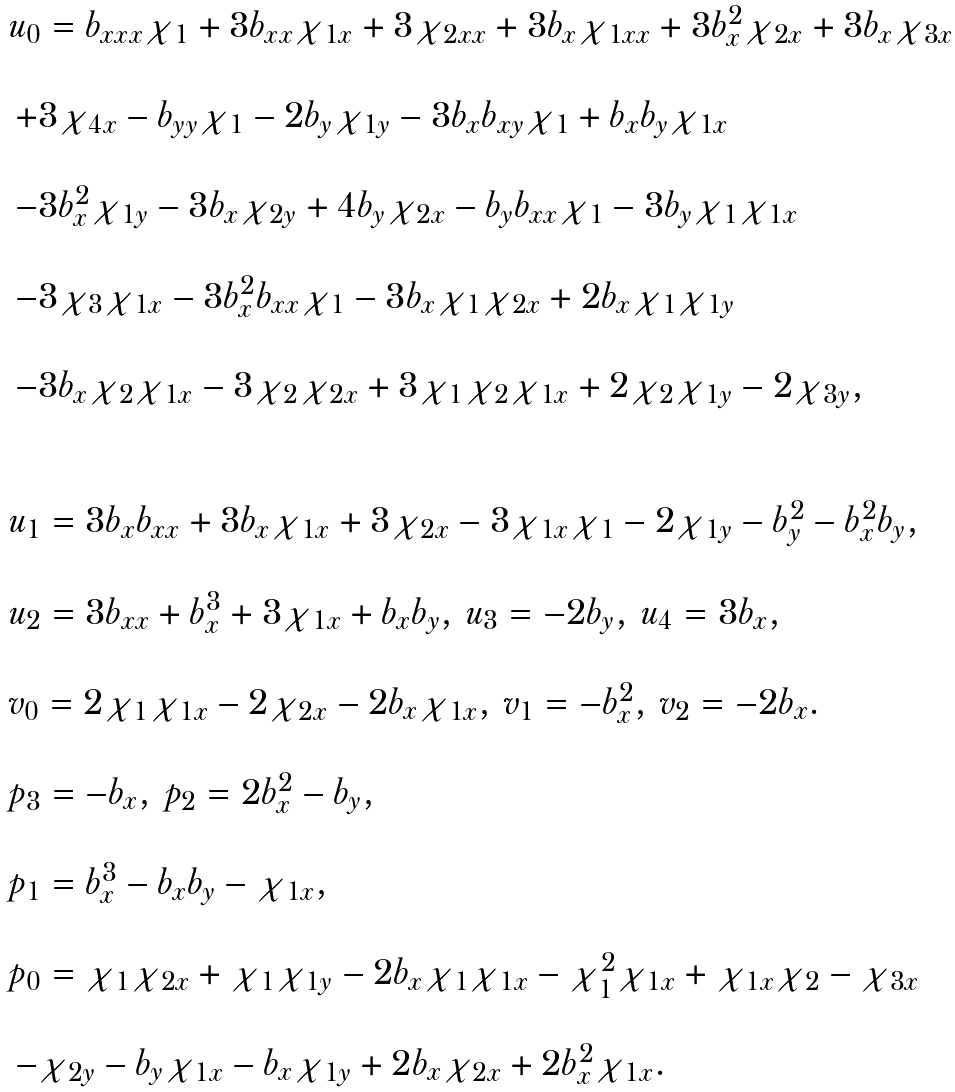<formula> <loc_0><loc_0><loc_500><loc_500>\begin{array} { l } u _ { 0 } = b _ { x x x } \chi _ { 1 } + 3 b _ { x x } \chi _ { 1 x } + 3 \chi _ { 2 x x } + 3 b _ { x } \chi _ { 1 x x } + 3 b _ { x } ^ { 2 } \chi _ { 2 x } + 3 b _ { x } \chi _ { 3 x } \\ \\ \, + 3 \chi _ { 4 x } - b _ { y y } \chi _ { 1 } - 2 b _ { y } \chi _ { 1 y } - 3 b _ { x } b _ { x y } \chi _ { 1 } + b _ { x } b _ { y } \chi _ { 1 x } \\ \\ \, - 3 b _ { x } ^ { 2 } \chi _ { 1 y } - 3 b _ { x } \chi _ { 2 y } + 4 b _ { y } \chi _ { 2 x } - b _ { y } b _ { x x } \chi _ { 1 } - 3 b _ { y } \chi _ { 1 } \chi _ { 1 x } \\ \\ \, - 3 \chi _ { 3 } \chi _ { 1 x } - 3 b _ { x } ^ { 2 } b _ { x x } \chi _ { 1 } - 3 b _ { x } \chi _ { 1 } \chi _ { 2 x } + 2 b _ { x } \chi _ { 1 } \chi _ { 1 y } \\ \\ \, - 3 b _ { x } \chi _ { 2 } \chi _ { 1 x } - 3 \chi _ { 2 } \chi _ { 2 x } + 3 \chi _ { 1 } \chi _ { 2 } \chi _ { 1 x } + 2 \chi _ { 2 } \chi _ { 1 y } - 2 \chi _ { 3 y } , \\ \\ \\ u _ { 1 } = 3 b _ { x } b _ { x x } + 3 b _ { x } \chi _ { 1 x } + 3 \chi _ { 2 x } - 3 \chi _ { 1 x } \chi _ { 1 } - 2 \chi _ { 1 y } - b _ { y } ^ { 2 } - b _ { x } ^ { 2 } b _ { y } , \\ \\ u _ { 2 } = 3 b _ { x x } + b _ { x } ^ { 3 } + 3 \chi _ { 1 x } + b _ { x } b _ { y } , \, u _ { 3 } = - 2 b _ { y } , \, u _ { 4 } = 3 b _ { x } , \\ \\ v _ { 0 } = 2 \chi _ { 1 } \chi _ { 1 x } - 2 \chi _ { 2 x } - 2 b _ { x } \chi _ { 1 x } , \, v _ { 1 } = - b _ { x } ^ { 2 } , \, v _ { 2 } = - 2 b _ { x } . \\ \\ p _ { 3 } = - b _ { x } , \, p _ { 2 } = 2 b _ { x } ^ { 2 } - b _ { y } , \\ \\ p _ { 1 } = b _ { x } ^ { 3 } - b _ { x } b _ { y } - \chi _ { 1 x } , \\ \\ p _ { 0 } = \chi _ { 1 } \chi _ { 2 x } + \chi _ { 1 } \chi _ { 1 y } - 2 b _ { x } \chi _ { 1 } \chi _ { 1 x } - \chi _ { 1 } ^ { 2 } \chi _ { 1 x } + \chi _ { 1 x } \chi _ { 2 } - \chi _ { 3 x } \\ \\ \, - \chi _ { 2 y } - b _ { y } \chi _ { 1 x } - b _ { x } \chi _ { 1 y } + 2 b _ { x } \chi _ { 2 x } + 2 b _ { x } ^ { 2 } \chi _ { 1 x } . \end{array}</formula> 